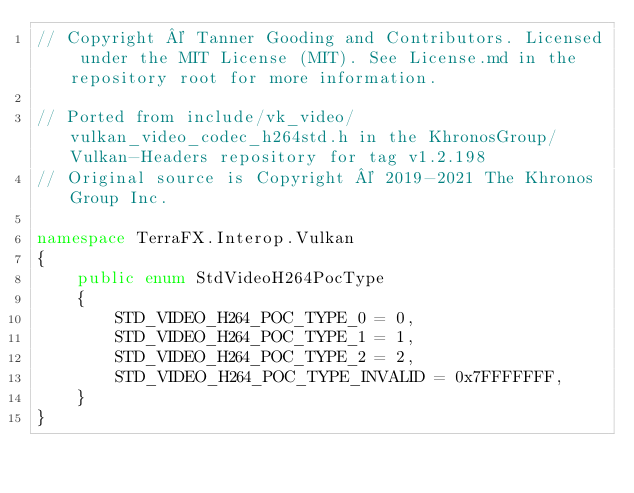<code> <loc_0><loc_0><loc_500><loc_500><_C#_>// Copyright © Tanner Gooding and Contributors. Licensed under the MIT License (MIT). See License.md in the repository root for more information.

// Ported from include/vk_video/vulkan_video_codec_h264std.h in the KhronosGroup/Vulkan-Headers repository for tag v1.2.198
// Original source is Copyright © 2019-2021 The Khronos Group Inc.

namespace TerraFX.Interop.Vulkan
{
    public enum StdVideoH264PocType
    {
        STD_VIDEO_H264_POC_TYPE_0 = 0,
        STD_VIDEO_H264_POC_TYPE_1 = 1,
        STD_VIDEO_H264_POC_TYPE_2 = 2,
        STD_VIDEO_H264_POC_TYPE_INVALID = 0x7FFFFFFF,
    }
}
</code> 